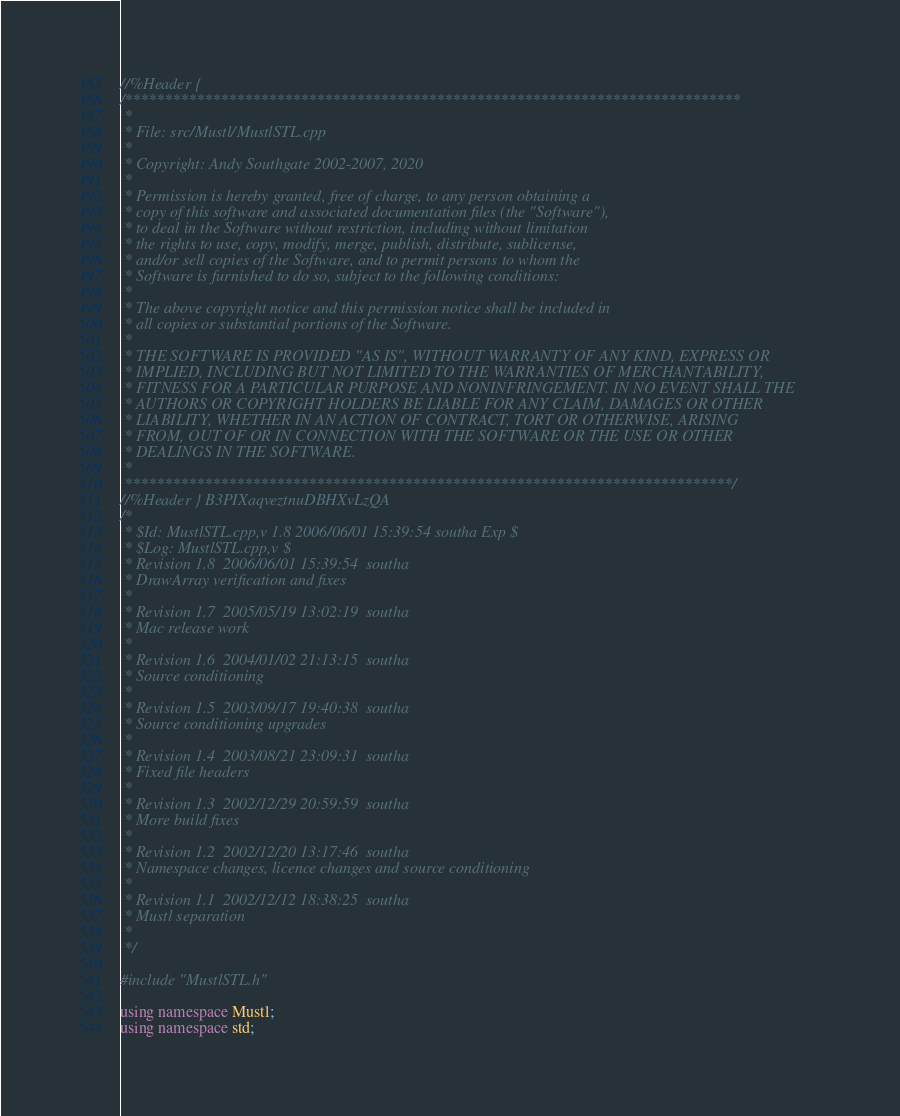Convert code to text. <code><loc_0><loc_0><loc_500><loc_500><_C++_>//%Header {
/*****************************************************************************
 *
 * File: src/Mustl/MustlSTL.cpp
 *
 * Copyright: Andy Southgate 2002-2007, 2020
 *
 * Permission is hereby granted, free of charge, to any person obtaining a
 * copy of this software and associated documentation files (the "Software"),
 * to deal in the Software without restriction, including without limitation
 * the rights to use, copy, modify, merge, publish, distribute, sublicense,
 * and/or sell copies of the Software, and to permit persons to whom the
 * Software is furnished to do so, subject to the following conditions:
 *
 * The above copyright notice and this permission notice shall be included in
 * all copies or substantial portions of the Software.
 *
 * THE SOFTWARE IS PROVIDED "AS IS", WITHOUT WARRANTY OF ANY KIND, EXPRESS OR
 * IMPLIED, INCLUDING BUT NOT LIMITED TO THE WARRANTIES OF MERCHANTABILITY,
 * FITNESS FOR A PARTICULAR PURPOSE AND NONINFRINGEMENT. IN NO EVENT SHALL THE
 * AUTHORS OR COPYRIGHT HOLDERS BE LIABLE FOR ANY CLAIM, DAMAGES OR OTHER
 * LIABILITY, WHETHER IN AN ACTION OF CONTRACT, TORT OR OTHERWISE, ARISING
 * FROM, OUT OF OR IN CONNECTION WITH THE SOFTWARE OR THE USE OR OTHER
 * DEALINGS IN THE SOFTWARE.
 *
 ****************************************************************************/
//%Header } B3PIXaqveztnuDBHXvLzQA
/*
 * $Id: MustlSTL.cpp,v 1.8 2006/06/01 15:39:54 southa Exp $
 * $Log: MustlSTL.cpp,v $
 * Revision 1.8  2006/06/01 15:39:54  southa
 * DrawArray verification and fixes
 *
 * Revision 1.7  2005/05/19 13:02:19  southa
 * Mac release work
 *
 * Revision 1.6  2004/01/02 21:13:15  southa
 * Source conditioning
 *
 * Revision 1.5  2003/09/17 19:40:38  southa
 * Source conditioning upgrades
 *
 * Revision 1.4  2003/08/21 23:09:31  southa
 * Fixed file headers
 *
 * Revision 1.3  2002/12/29 20:59:59  southa
 * More build fixes
 *
 * Revision 1.2  2002/12/20 13:17:46  southa
 * Namespace changes, licence changes and source conditioning
 *
 * Revision 1.1  2002/12/12 18:38:25  southa
 * Mustl separation
 *
 */

#include "MustlSTL.h"

using namespace Mustl;
using namespace std;

</code> 